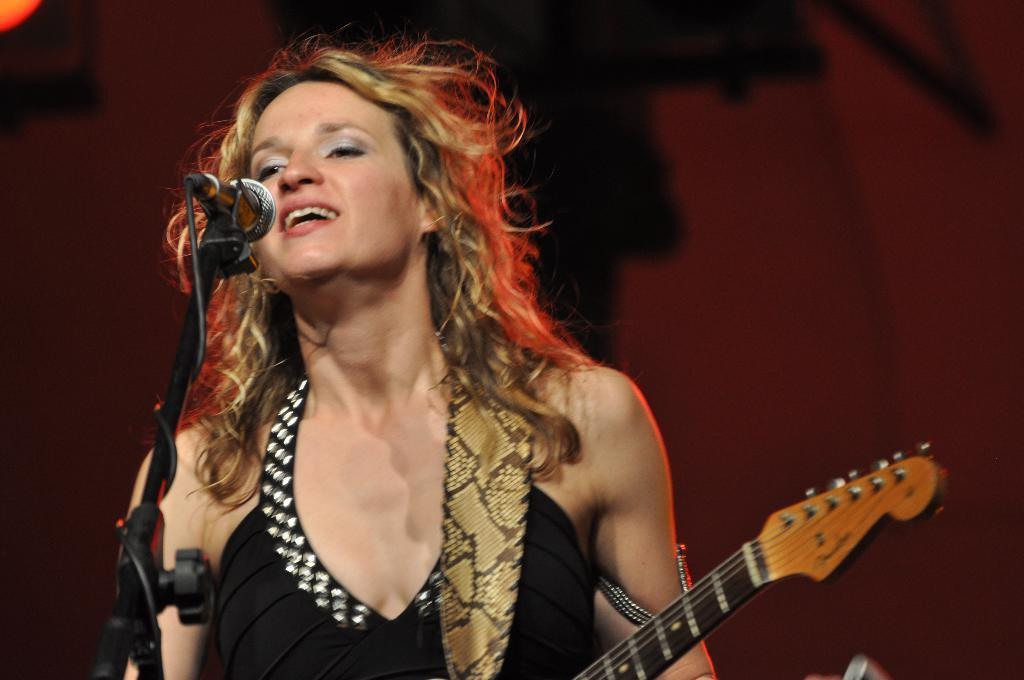Who is the main subject in the image? There is a woman in the image. What is the woman doing in the image? The woman is singing in front of a microphone. What musical instrument is present in the image? There is a guitar in the image. What is the color of the woman's hair? The woman's hair color is light brown. What is the woman wearing in the image? The woman is wearing a black dress. Can you see any fish swimming in the image? There are no fish present in the image. What type of rice is being cooked in the background of the image? There is no rice or cooking activity visible in the image. 